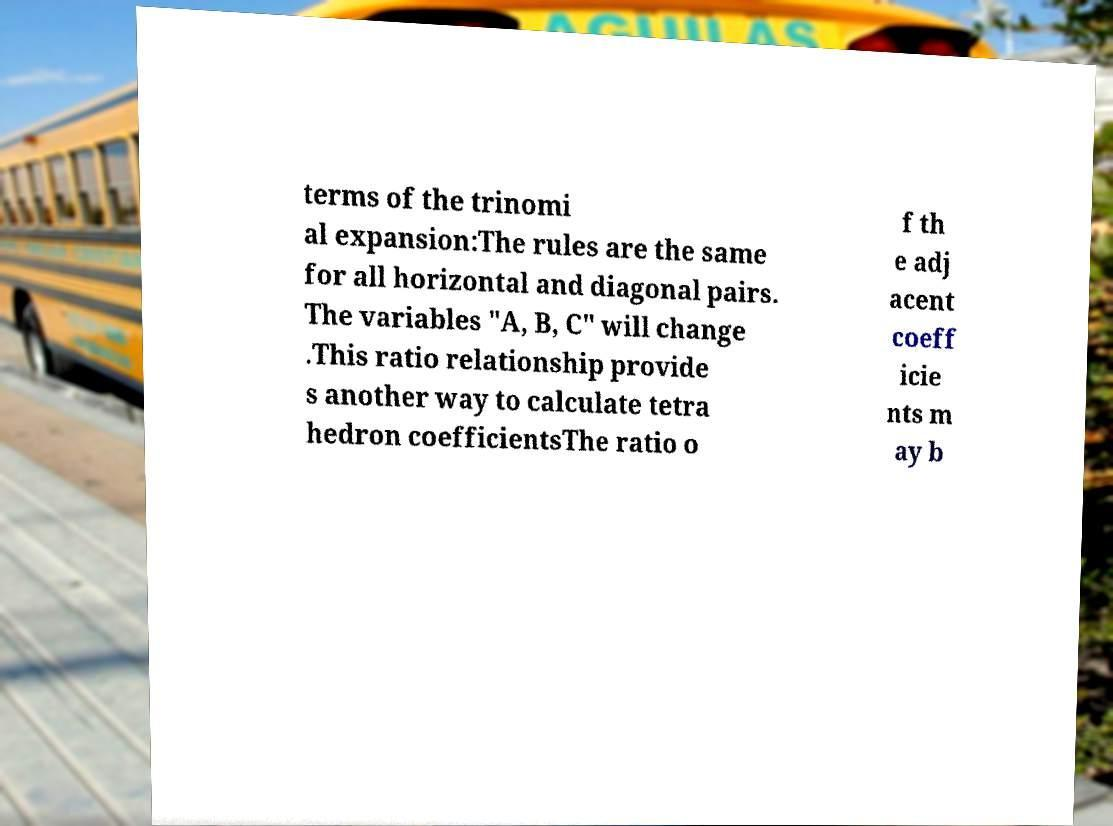For documentation purposes, I need the text within this image transcribed. Could you provide that? terms of the trinomi al expansion:The rules are the same for all horizontal and diagonal pairs. The variables "A, B, C" will change .This ratio relationship provide s another way to calculate tetra hedron coefficientsThe ratio o f th e adj acent coeff icie nts m ay b 